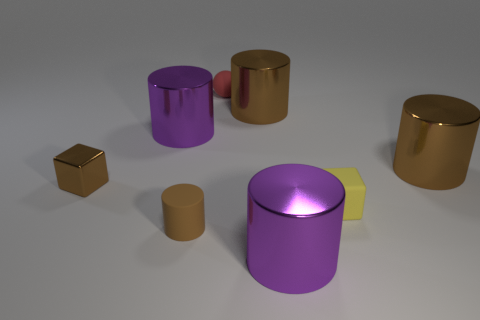Subtract all brown blocks. How many brown cylinders are left? 3 Subtract all cyan cylinders. Subtract all cyan cubes. How many cylinders are left? 5 Add 1 brown metal cylinders. How many objects exist? 9 Subtract all spheres. How many objects are left? 7 Add 4 red rubber things. How many red rubber things are left? 5 Add 3 tiny brown cylinders. How many tiny brown cylinders exist? 4 Subtract 0 green blocks. How many objects are left? 8 Subtract all big blue matte blocks. Subtract all yellow objects. How many objects are left? 7 